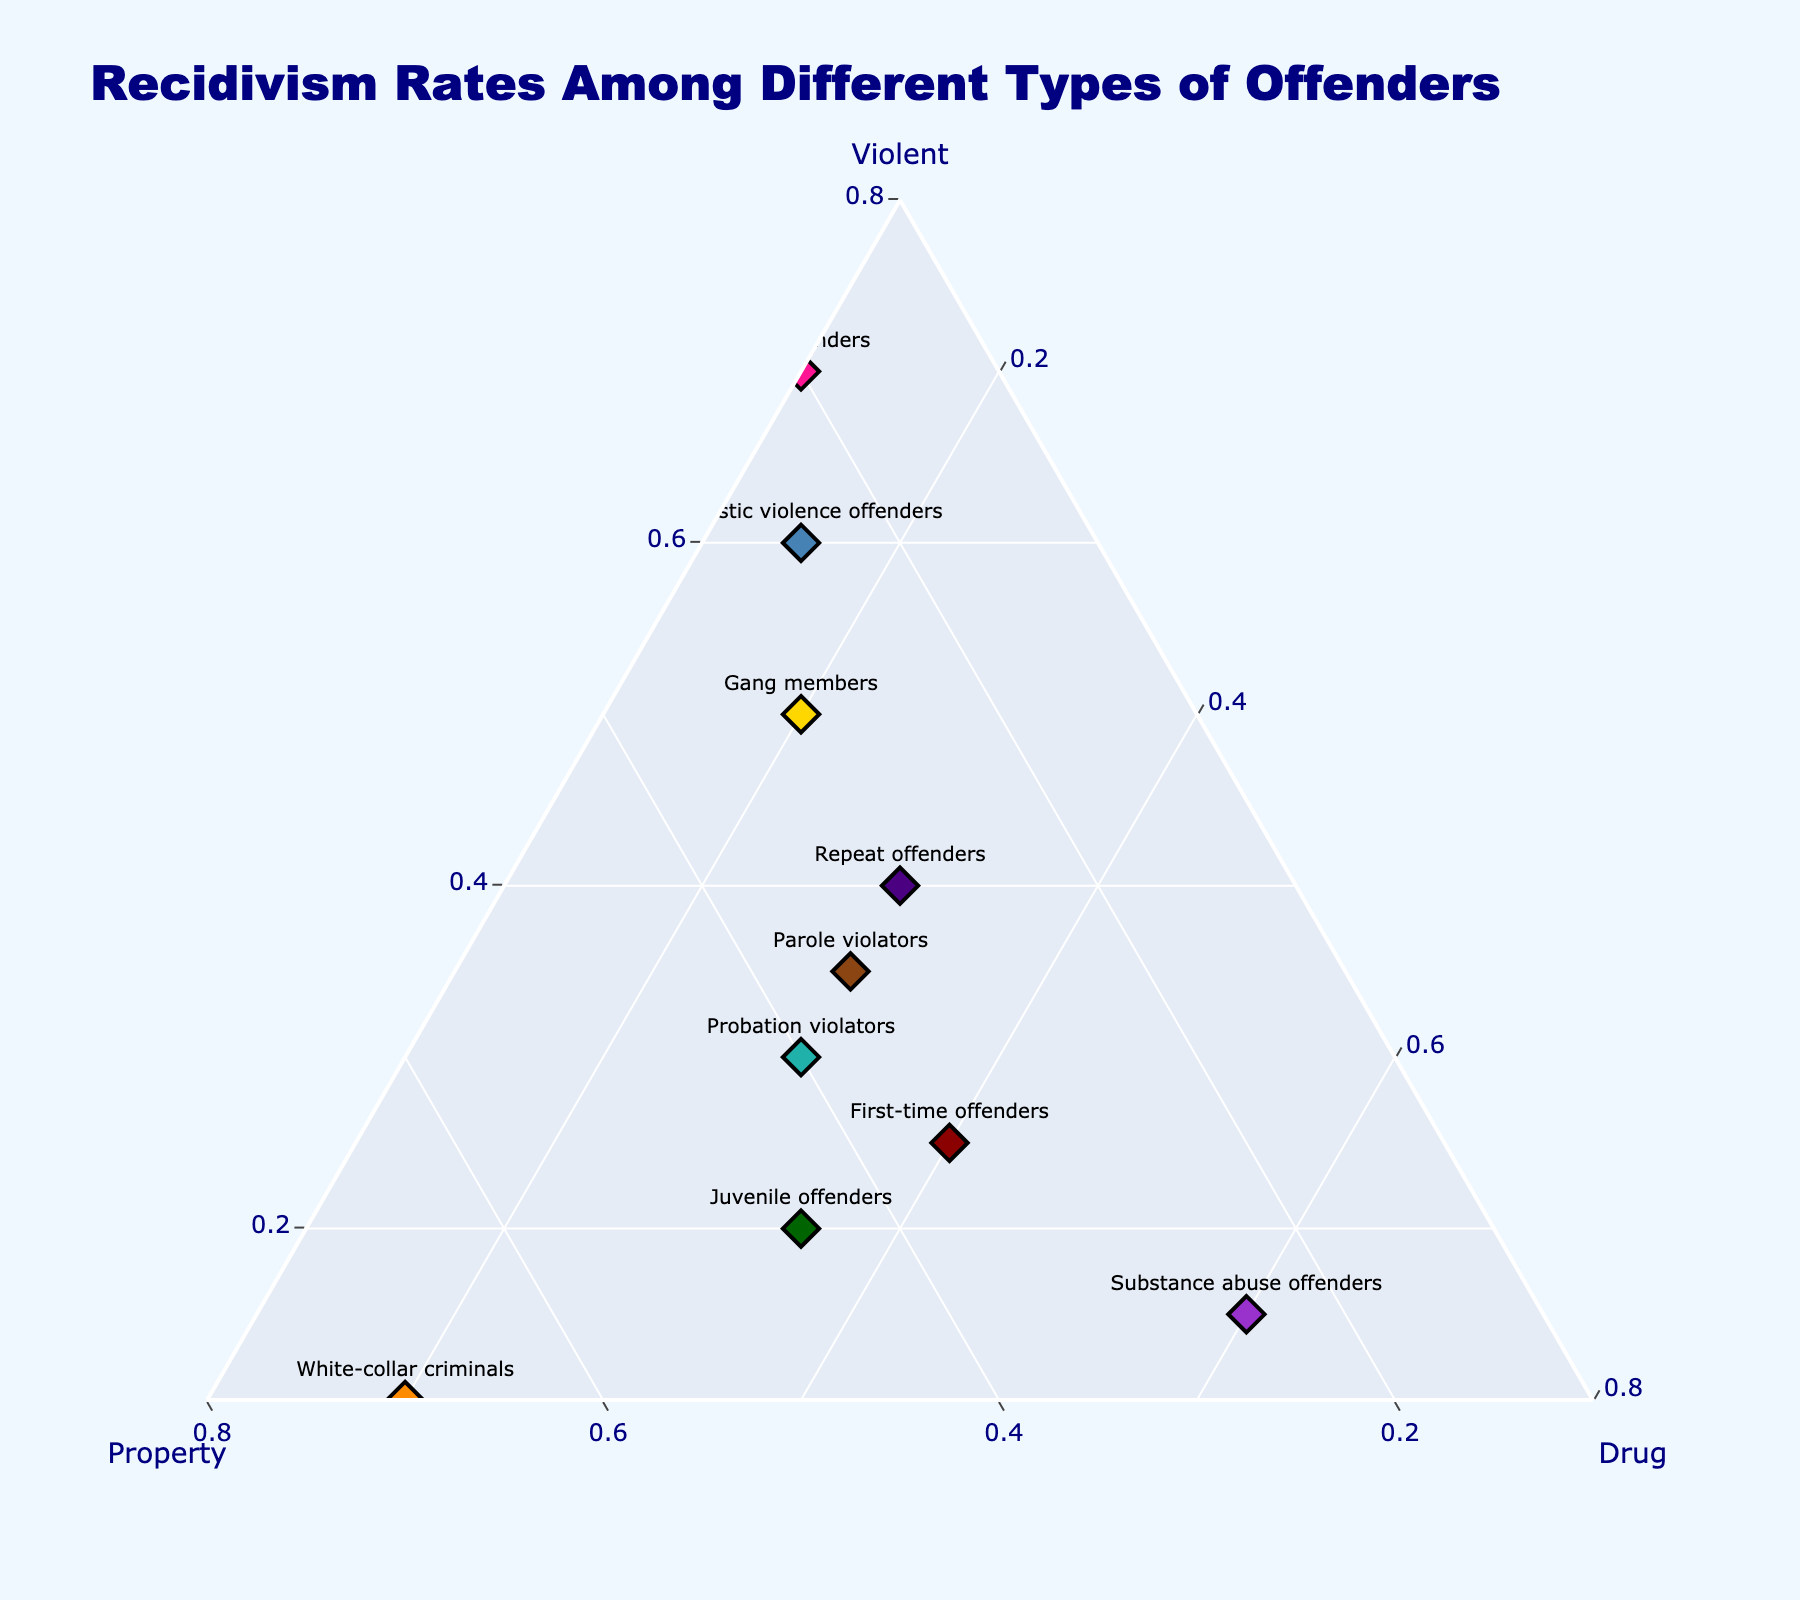What is the title of the figure? The title is usually prominently displayed at the top of the figure. The title of this figure is "Recidivism Rates Among Different Types of Offenders".
Answer: Recidivism Rates Among Different Types of Offenders How many offender types are represented in the figure? To find the number of offender types, count the number of labels or markers on the ternary plot. Each marker should have a corresponding offender type. There are 10 markers.
Answer: 10 Which offender type has the highest rate of recidivism for violent crimes? Look at the axis labeled "Violent" and find the offender type with the marker closest to the highest value on that axis. "Sex offenders" have the highest rate at 70%.
Answer: Sex offenders Which offender type has the highest percentage of property crime recidivism? Inspect the axis labeled "Property" and identify the offender type with the highest value on that axis. "White-collar criminals" have a 70% property crime recidivism rate.
Answer: White-collar criminals Do first-time offenders or repeat offenders have a higher rate of drug offense recidivism? Compare the values on the axis labeled "Drug" for both first-time offenders (40%) and repeat offenders (30%). First-time offenders have a higher rate.
Answer: First-time offenders Which three offender types have the lowest rate of violent crime recidivism? Identify the three lowest values on the "Violent" axis. The three lowest rates belong to "White-collar criminals" (10%), "Substance abuse offenders" (15%), and "Juvenile offenders" (20%).
Answer: White-collar criminals, Substance abuse offenders, Juvenile offenders Calculate the average rate of drug offense recidivism for first-time offenders, gang members, and probation violators. Average the "Drug" values for the three groups: (40% + 20% + 30%) / 3 = 30%.
Answer: 30% Which offender type shows a balanced distribution among violent, property, and drug recidivism rates? Look for an offender type whose rates across all three categories are relatively equal. "Parole violators" have rates of 35% for violent, 35% for property, and 30% for drug offenses.
Answer: Parole violators Between gang members and domestic violence offenders, which type has a higher violent crime recidivism rate, and by how much? Compare the "Violent" values for both. Gang members have 50% and domestic violence offenders have 60%. The difference is 10%.
Answer: Domestic violence offenders by 10% Which category (Violent, Property, or Drug recidivism) shows the highest rate for substance abuse offenders? Identify the highest value for "Substance abuse offenders" across the three categories. The highest value is 60% for Drug recidivism.
Answer: Drug recidivism 